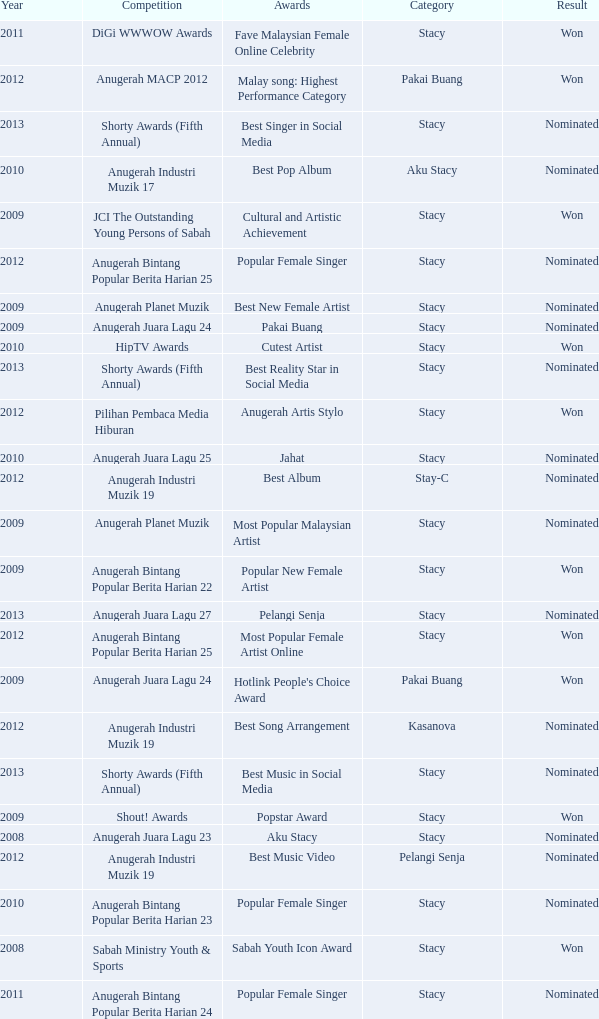What year has Stacy as the category and award of Best Reality Star in Social Media? 2013.0. 